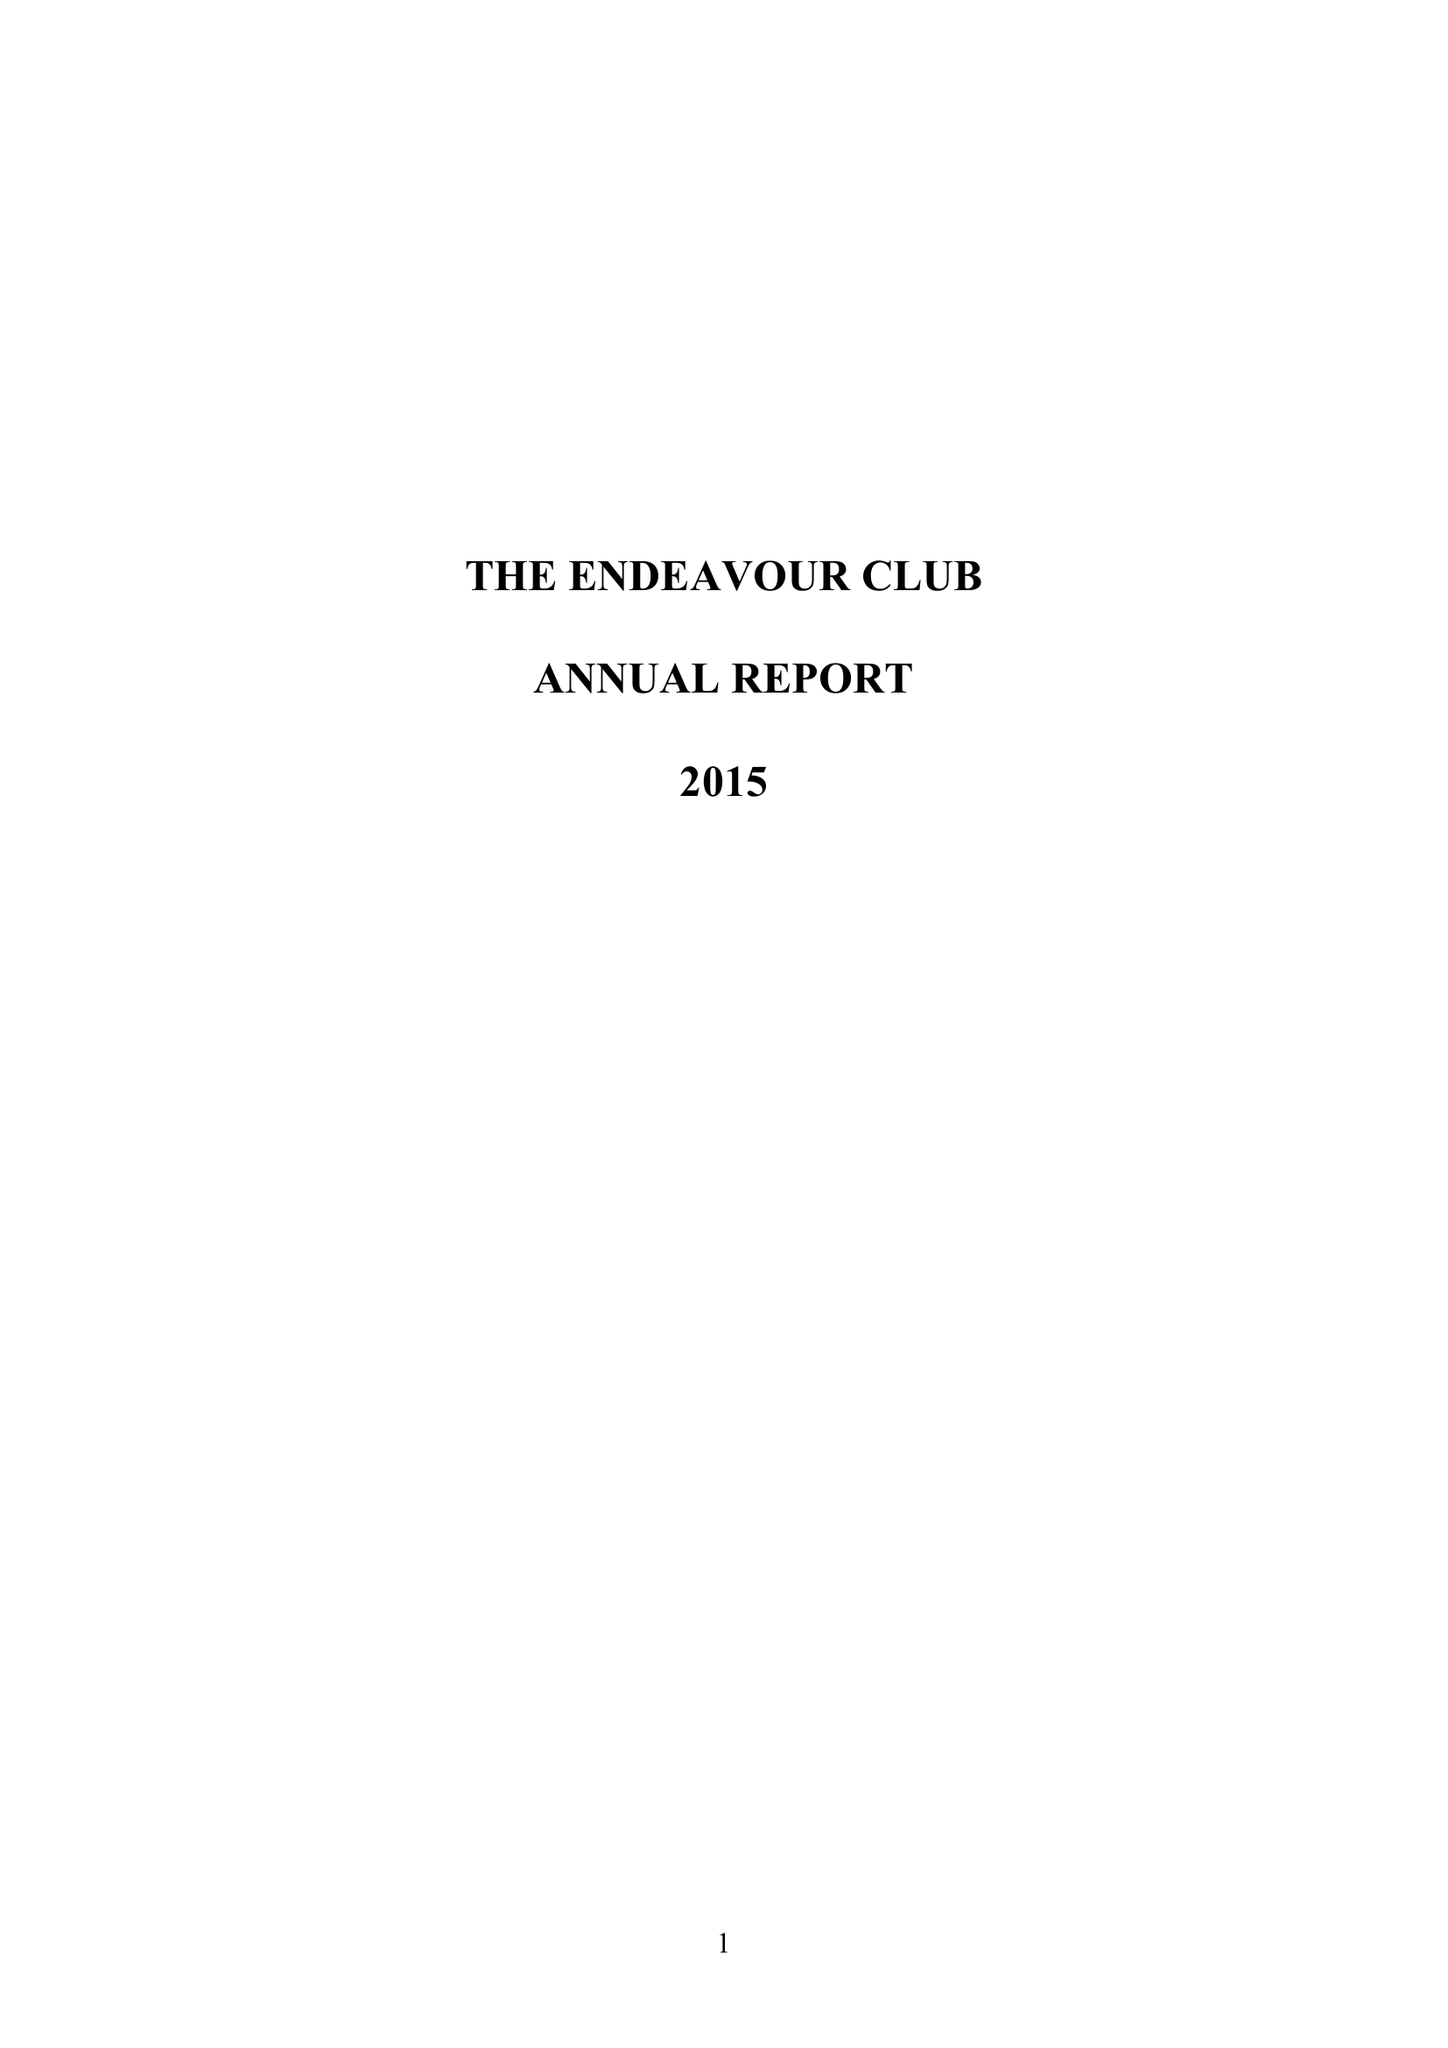What is the value for the address__post_town?
Answer the question using a single word or phrase. MORDEN 